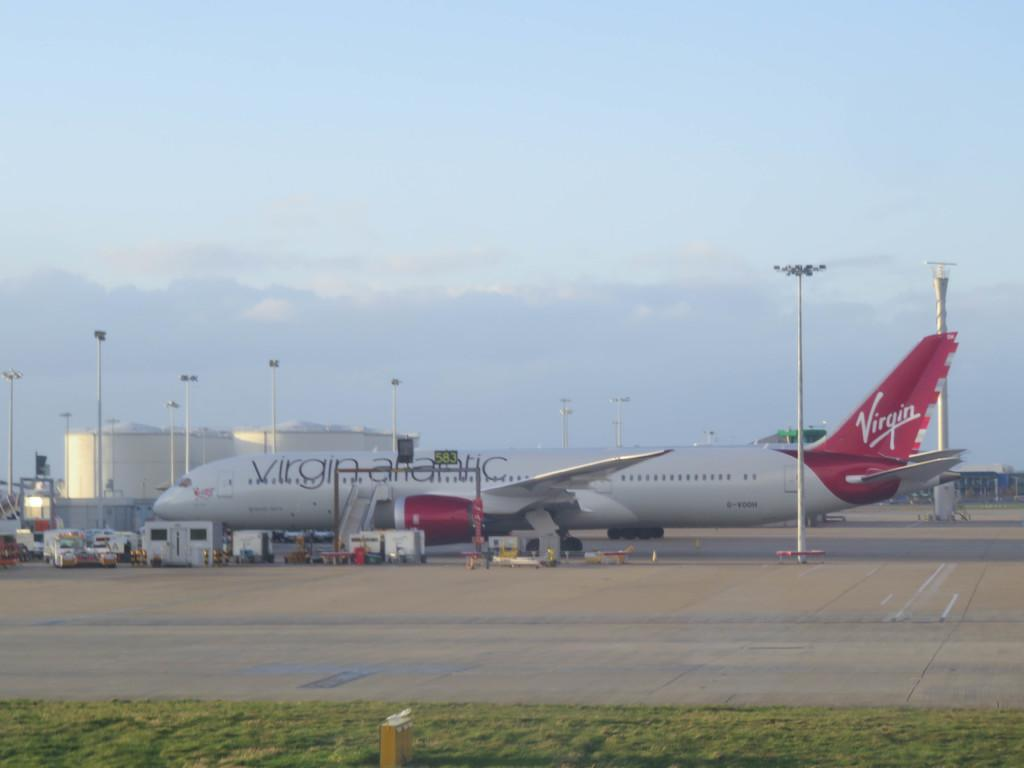<image>
Create a compact narrative representing the image presented. Virgin Atlantic airplane for the logo virgin on the airplane. 